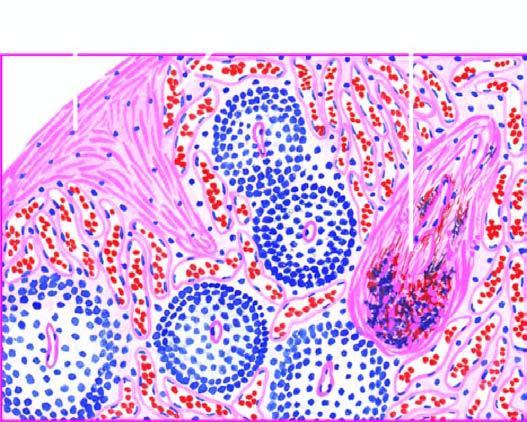s the alveolar lumina increased fibrosis in the red pulp, capsule and the trabeculae?
Answer the question using a single word or phrase. No 